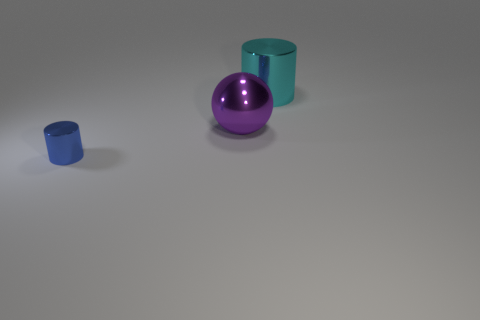Add 2 large gray metal things. How many objects exist? 5 Subtract 1 cylinders. How many cylinders are left? 1 Subtract all cyan cylinders. How many cylinders are left? 1 Add 3 big purple shiny objects. How many big purple shiny objects are left? 4 Add 3 large purple rubber spheres. How many large purple rubber spheres exist? 3 Subtract 0 red balls. How many objects are left? 3 Subtract all cylinders. How many objects are left? 1 Subtract all yellow cylinders. Subtract all purple cubes. How many cylinders are left? 2 Subtract all yellow metal balls. Subtract all large purple metal spheres. How many objects are left? 2 